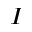Convert formula to latex. <formula><loc_0><loc_0><loc_500><loc_500>_ { I }</formula> 